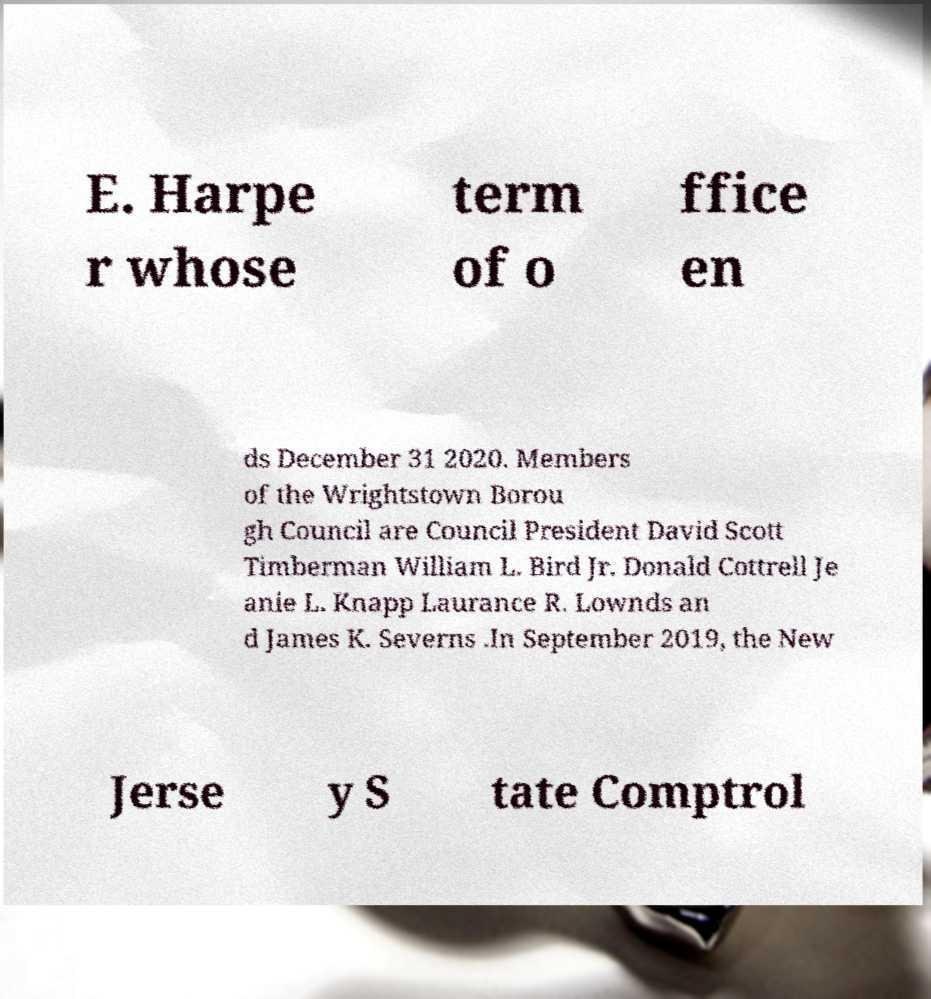Could you assist in decoding the text presented in this image and type it out clearly? E. Harpe r whose term of o ffice en ds December 31 2020. Members of the Wrightstown Borou gh Council are Council President David Scott Timberman William L. Bird Jr. Donald Cottrell Je anie L. Knapp Laurance R. Lownds an d James K. Severns .In September 2019, the New Jerse y S tate Comptrol 